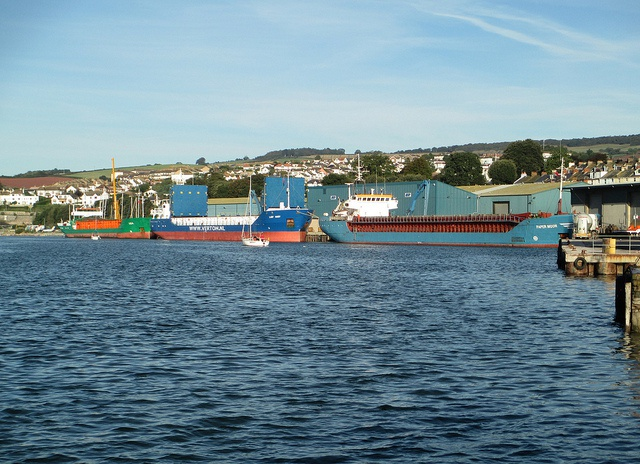Describe the objects in this image and their specific colors. I can see boat in darkgray, blue, ivory, brown, and gray tones and boat in darkgray, teal, maroon, black, and gray tones in this image. 